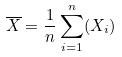Convert formula to latex. <formula><loc_0><loc_0><loc_500><loc_500>\overline { X } = \frac { 1 } { n } \sum _ { i = 1 } ^ { n } ( X _ { i } )</formula> 